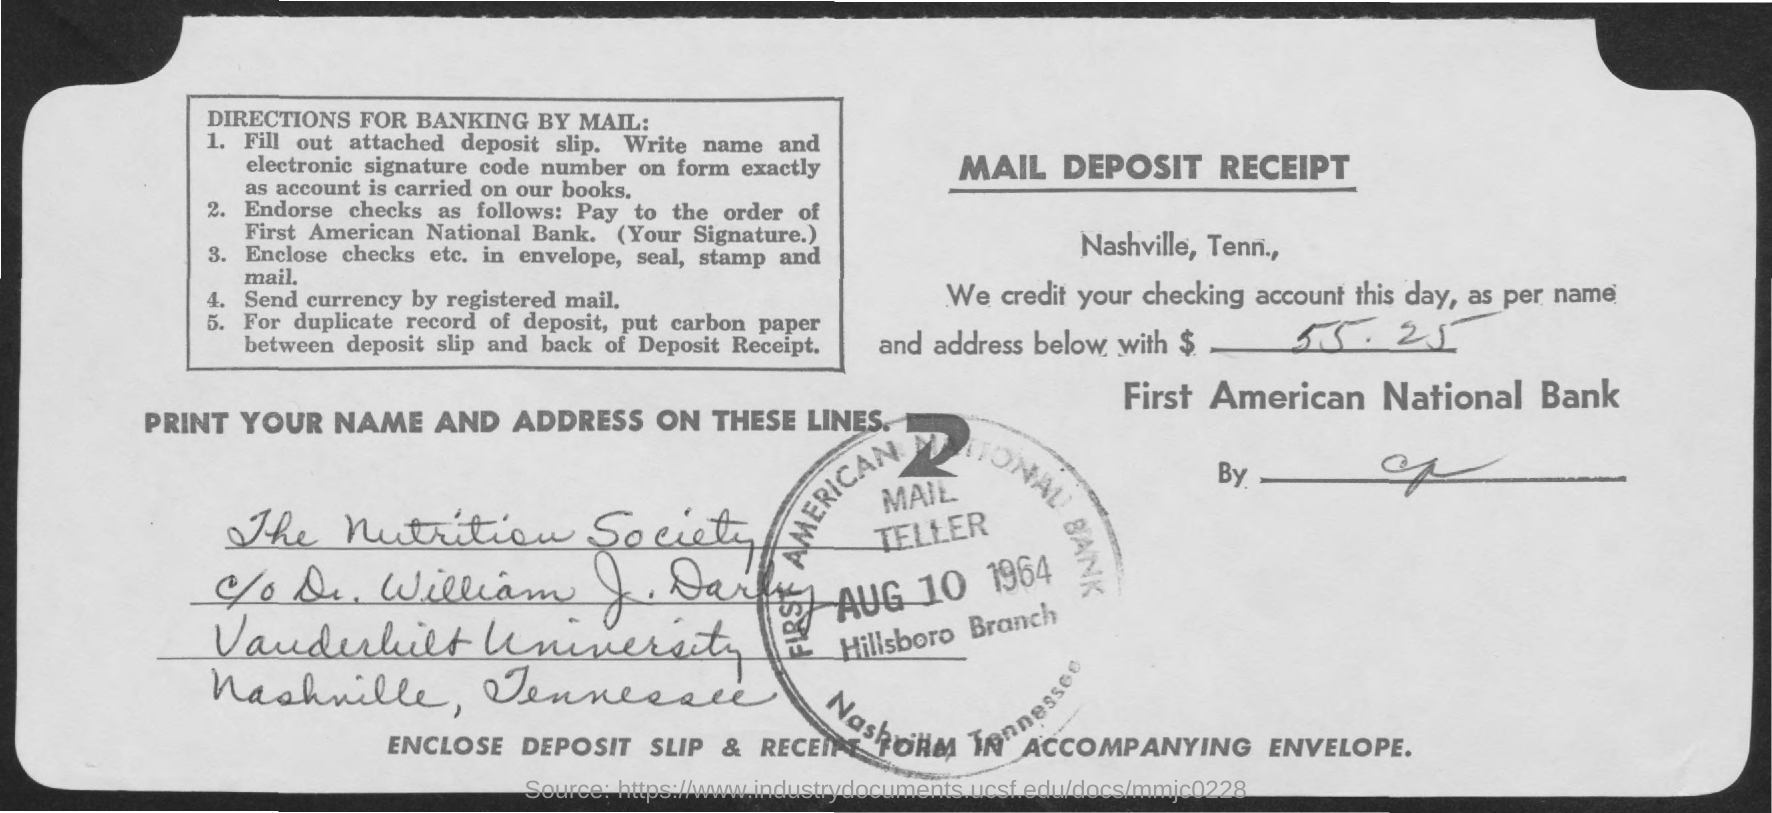What is the amount credited as mentioned in the mail deposit receipt?
Your answer should be very brief. 55.25. In whose account, the amount is credited?
Your answer should be very brief. The Nutrition Society, c/o Dr. William J. Darby. Which bank has credited the amount?
Make the answer very short. FIRST AMERICAN NATIONAL BANK. 